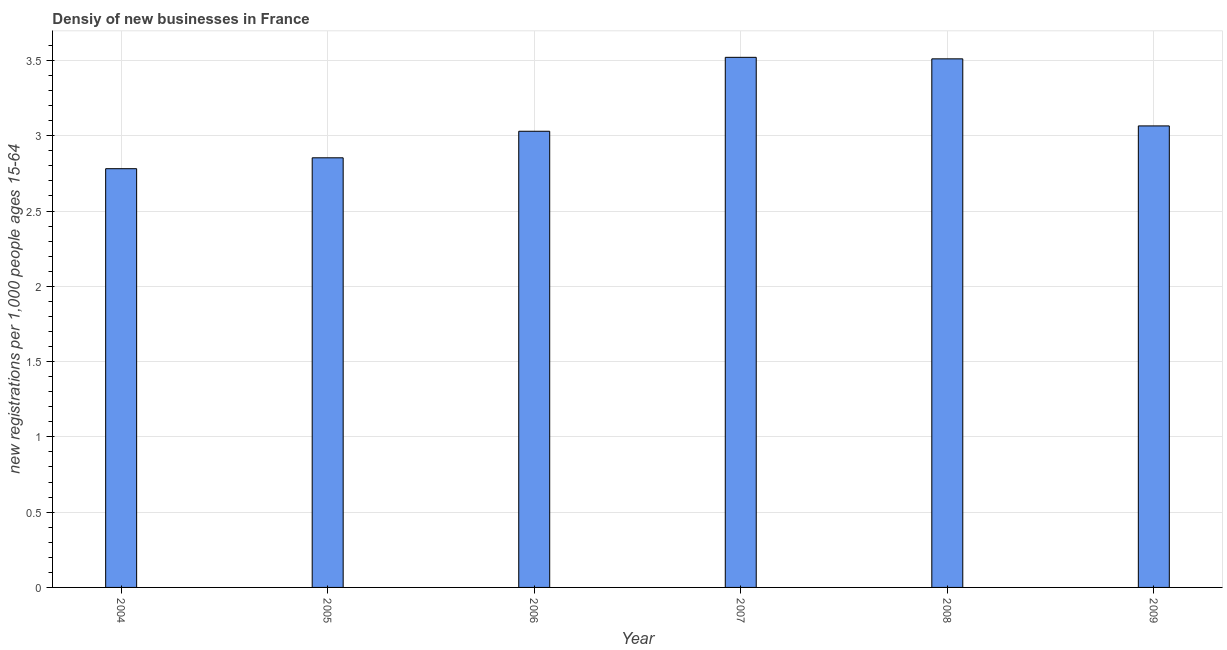Does the graph contain grids?
Your answer should be very brief. Yes. What is the title of the graph?
Provide a short and direct response. Densiy of new businesses in France. What is the label or title of the X-axis?
Make the answer very short. Year. What is the label or title of the Y-axis?
Your response must be concise. New registrations per 1,0 people ages 15-64. What is the density of new business in 2008?
Keep it short and to the point. 3.51. Across all years, what is the maximum density of new business?
Make the answer very short. 3.52. Across all years, what is the minimum density of new business?
Provide a short and direct response. 2.78. In which year was the density of new business maximum?
Provide a short and direct response. 2007. What is the sum of the density of new business?
Ensure brevity in your answer.  18.76. What is the difference between the density of new business in 2005 and 2007?
Ensure brevity in your answer.  -0.67. What is the average density of new business per year?
Offer a very short reply. 3.13. What is the median density of new business?
Your answer should be compact. 3.05. In how many years, is the density of new business greater than 2.1 ?
Give a very brief answer. 6. What is the ratio of the density of new business in 2005 to that in 2006?
Make the answer very short. 0.94. Is the density of new business in 2006 less than that in 2008?
Your answer should be very brief. Yes. What is the difference between the highest and the lowest density of new business?
Your answer should be compact. 0.74. How many bars are there?
Provide a short and direct response. 6. What is the difference between two consecutive major ticks on the Y-axis?
Provide a short and direct response. 0.5. Are the values on the major ticks of Y-axis written in scientific E-notation?
Your answer should be compact. No. What is the new registrations per 1,000 people ages 15-64 in 2004?
Offer a terse response. 2.78. What is the new registrations per 1,000 people ages 15-64 in 2005?
Your answer should be very brief. 2.85. What is the new registrations per 1,000 people ages 15-64 in 2006?
Give a very brief answer. 3.03. What is the new registrations per 1,000 people ages 15-64 of 2007?
Your response must be concise. 3.52. What is the new registrations per 1,000 people ages 15-64 in 2008?
Provide a short and direct response. 3.51. What is the new registrations per 1,000 people ages 15-64 of 2009?
Keep it short and to the point. 3.07. What is the difference between the new registrations per 1,000 people ages 15-64 in 2004 and 2005?
Your response must be concise. -0.07. What is the difference between the new registrations per 1,000 people ages 15-64 in 2004 and 2006?
Make the answer very short. -0.25. What is the difference between the new registrations per 1,000 people ages 15-64 in 2004 and 2007?
Give a very brief answer. -0.74. What is the difference between the new registrations per 1,000 people ages 15-64 in 2004 and 2008?
Offer a terse response. -0.73. What is the difference between the new registrations per 1,000 people ages 15-64 in 2004 and 2009?
Provide a short and direct response. -0.28. What is the difference between the new registrations per 1,000 people ages 15-64 in 2005 and 2006?
Your answer should be very brief. -0.18. What is the difference between the new registrations per 1,000 people ages 15-64 in 2005 and 2007?
Provide a short and direct response. -0.67. What is the difference between the new registrations per 1,000 people ages 15-64 in 2005 and 2008?
Provide a succinct answer. -0.66. What is the difference between the new registrations per 1,000 people ages 15-64 in 2005 and 2009?
Ensure brevity in your answer.  -0.21. What is the difference between the new registrations per 1,000 people ages 15-64 in 2006 and 2007?
Offer a very short reply. -0.49. What is the difference between the new registrations per 1,000 people ages 15-64 in 2006 and 2008?
Your answer should be compact. -0.48. What is the difference between the new registrations per 1,000 people ages 15-64 in 2006 and 2009?
Your answer should be compact. -0.04. What is the difference between the new registrations per 1,000 people ages 15-64 in 2007 and 2008?
Your response must be concise. 0.01. What is the difference between the new registrations per 1,000 people ages 15-64 in 2007 and 2009?
Ensure brevity in your answer.  0.46. What is the difference between the new registrations per 1,000 people ages 15-64 in 2008 and 2009?
Make the answer very short. 0.45. What is the ratio of the new registrations per 1,000 people ages 15-64 in 2004 to that in 2005?
Your answer should be compact. 0.97. What is the ratio of the new registrations per 1,000 people ages 15-64 in 2004 to that in 2006?
Give a very brief answer. 0.92. What is the ratio of the new registrations per 1,000 people ages 15-64 in 2004 to that in 2007?
Offer a very short reply. 0.79. What is the ratio of the new registrations per 1,000 people ages 15-64 in 2004 to that in 2008?
Keep it short and to the point. 0.79. What is the ratio of the new registrations per 1,000 people ages 15-64 in 2004 to that in 2009?
Your answer should be very brief. 0.91. What is the ratio of the new registrations per 1,000 people ages 15-64 in 2005 to that in 2006?
Your answer should be compact. 0.94. What is the ratio of the new registrations per 1,000 people ages 15-64 in 2005 to that in 2007?
Provide a succinct answer. 0.81. What is the ratio of the new registrations per 1,000 people ages 15-64 in 2005 to that in 2008?
Keep it short and to the point. 0.81. What is the ratio of the new registrations per 1,000 people ages 15-64 in 2005 to that in 2009?
Provide a short and direct response. 0.93. What is the ratio of the new registrations per 1,000 people ages 15-64 in 2006 to that in 2007?
Ensure brevity in your answer.  0.86. What is the ratio of the new registrations per 1,000 people ages 15-64 in 2006 to that in 2008?
Your response must be concise. 0.86. What is the ratio of the new registrations per 1,000 people ages 15-64 in 2006 to that in 2009?
Your response must be concise. 0.99. What is the ratio of the new registrations per 1,000 people ages 15-64 in 2007 to that in 2009?
Make the answer very short. 1.15. What is the ratio of the new registrations per 1,000 people ages 15-64 in 2008 to that in 2009?
Make the answer very short. 1.15. 